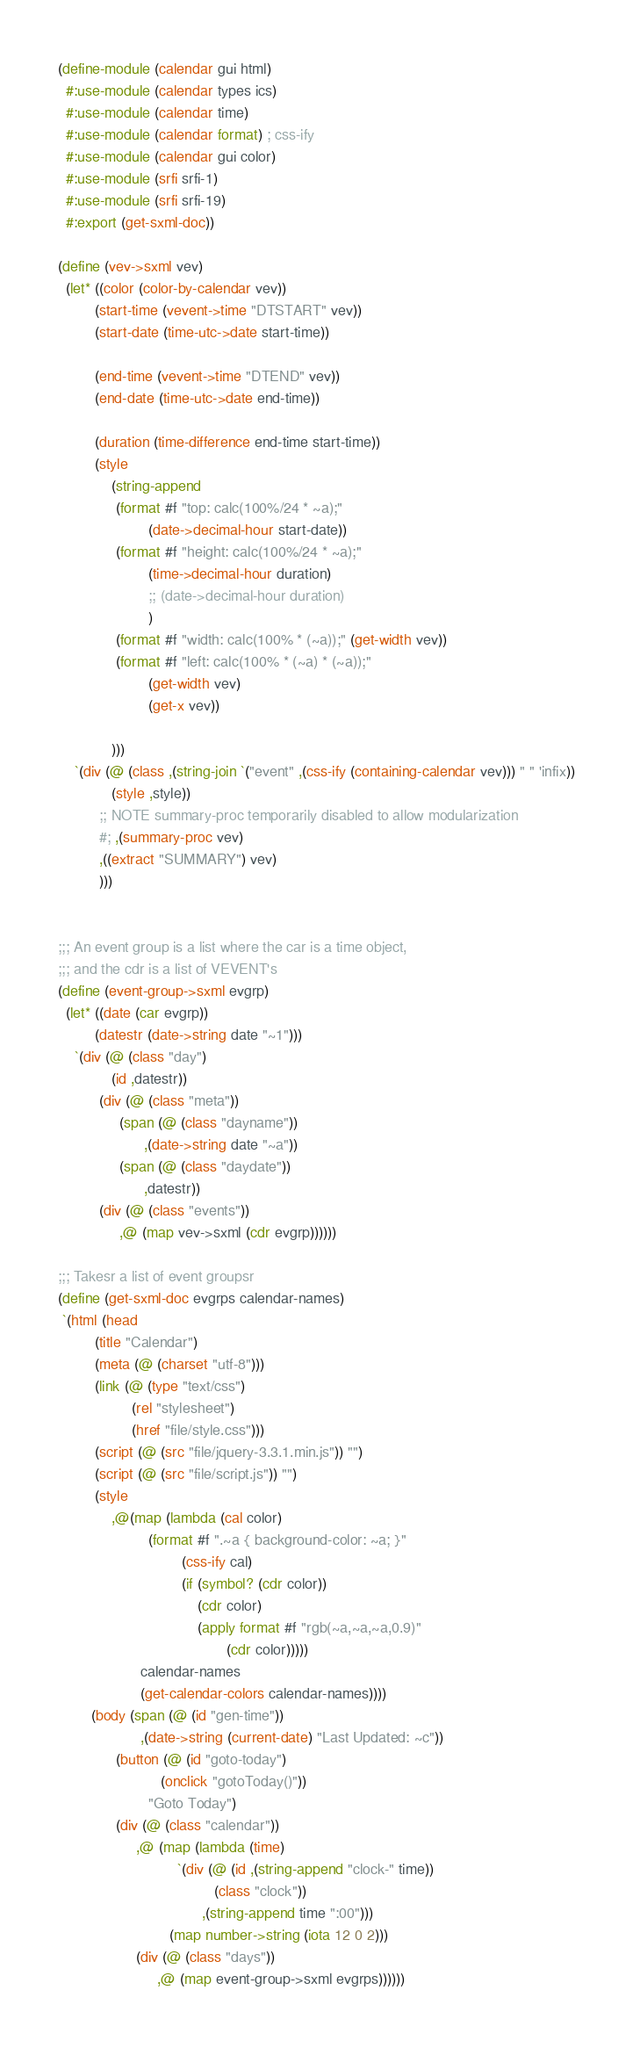Convert code to text. <code><loc_0><loc_0><loc_500><loc_500><_Scheme_>(define-module (calendar gui html)
  #:use-module (calendar types ics)
  #:use-module (calendar time)
  #:use-module (calendar format) ; css-ify
  #:use-module (calendar gui color)
  #:use-module (srfi srfi-1)
  #:use-module (srfi srfi-19)
  #:export (get-sxml-doc)) 

(define (vev->sxml vev)
  (let* ((color (color-by-calendar vev))
         (start-time (vevent->time "DTSTART" vev))
         (start-date (time-utc->date start-time))

         (end-time (vevent->time "DTEND" vev))
         (end-date (time-utc->date end-time))

         (duration (time-difference end-time start-time))
         (style
             (string-append
              (format #f "top: calc(100%/24 * ~a);"
                      (date->decimal-hour start-date))
              (format #f "height: calc(100%/24 * ~a);"
                      (time->decimal-hour duration)
                      ;; (date->decimal-hour duration)
                      )
              (format #f "width: calc(100% * (~a));" (get-width vev))
              (format #f "left: calc(100% * (~a) * (~a));"
                      (get-width vev)
                      (get-x vev))
              
             )))
    `(div (@ (class ,(string-join `("event" ,(css-ify (containing-calendar vev))) " " 'infix))
             (style ,style))
          ;; NOTE summary-proc temporarily disabled to allow modularization 
          #; ,(summary-proc vev)
          ,((extract "SUMMARY") vev)
          )))


;;; An event group is a list where the car is a time object,
;;; and the cdr is a list of VEVENT's
(define (event-group->sxml evgrp)
  (let* ((date (car evgrp))
         (datestr (date->string date "~1")))
    `(div (@ (class "day")
             (id ,datestr))
          (div (@ (class "meta"))
               (span (@ (class "dayname"))
                     ,(date->string date "~a"))
               (span (@ (class "daydate"))
                     ,datestr))
          (div (@ (class "events"))
               ,@ (map vev->sxml (cdr evgrp))))))

;;; Takesr a list of event groupsr
(define (get-sxml-doc evgrps calendar-names)
 `(html (head
         (title "Calendar")
         (meta (@ (charset "utf-8")))
         (link (@ (type "text/css")
                  (rel "stylesheet")
                  (href "file/style.css")))
         (script (@ (src "file/jquery-3.3.1.min.js")) "")
         (script (@ (src "file/script.js")) "")
         (style
             ,@(map (lambda (cal color)
                      (format #f ".~a { background-color: ~a; }"
                              (css-ify cal)
                              (if (symbol? (cdr color))
                                  (cdr color)
                                  (apply format #f "rgb(~a,~a,~a,0.9)"
                                         (cdr color)))))
                    calendar-names
                    (get-calendar-colors calendar-names))))
        (body (span (@ (id "gen-time"))
                    ,(date->string (current-date) "Last Updated: ~c"))
              (button (@ (id "goto-today")
                         (onclick "gotoToday()"))
                      "Goto Today")
              (div (@ (class "calendar"))
                   ,@ (map (lambda (time)
                             `(div (@ (id ,(string-append "clock-" time))
                                      (class "clock"))
                                   ,(string-append time ":00")))
                           (map number->string (iota 12 0 2)))
                   (div (@ (class "days"))
                        ,@ (map event-group->sxml evgrps))))))
</code> 